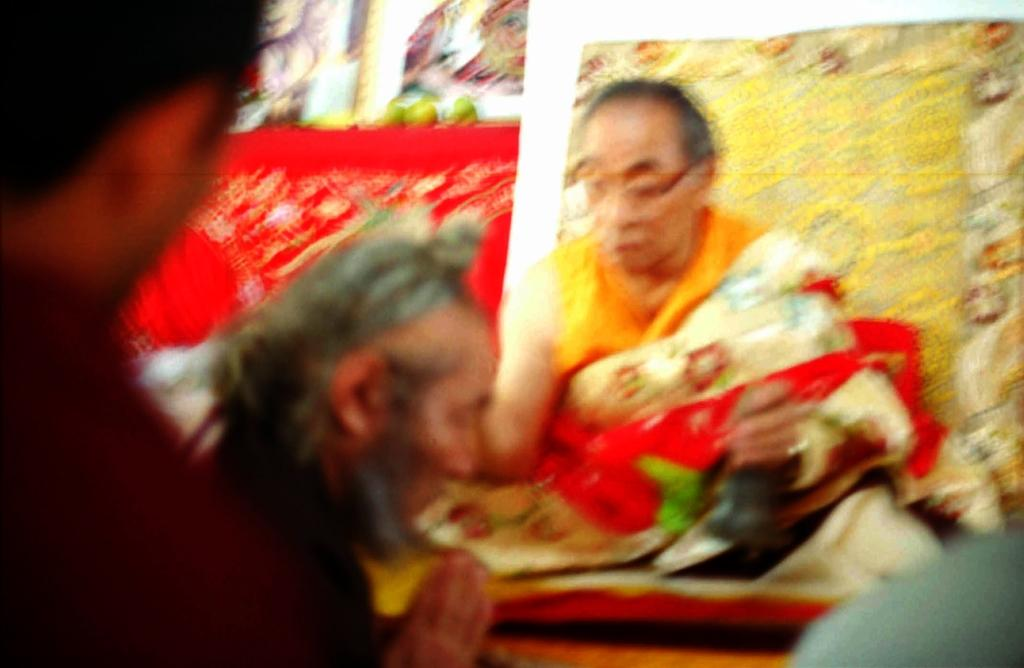How many people are in the image? There are three people in the image. What can be inferred about the three people based on their appearance? The three people are likely Buddhist monks or practitioners. Are there any other people visible in the image? Yes, there are two additional people behind the three main subjects. What type of food can be seen in the image? There are fruits visible in the image. What color is the cloth present in the image? There is a red color cloth in the image. What brand of toothpaste is being used by the people in the image? There is no toothpaste visible in the image, and it cannot be determined if any of the people are using toothpaste. What type of trousers are the people wearing in the image? The provided facts do not mention the type of trousers worn by the people in the image. 